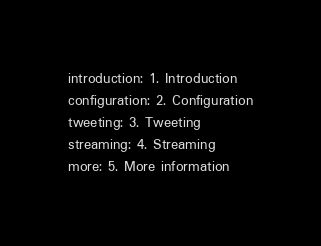<code> <loc_0><loc_0><loc_500><loc_500><_YAML_>introduction: 1. Introduction
configuration: 2. Configuration
tweeting: 3. Tweeting
streaming: 4. Streaming
more: 5. More information

</code> 